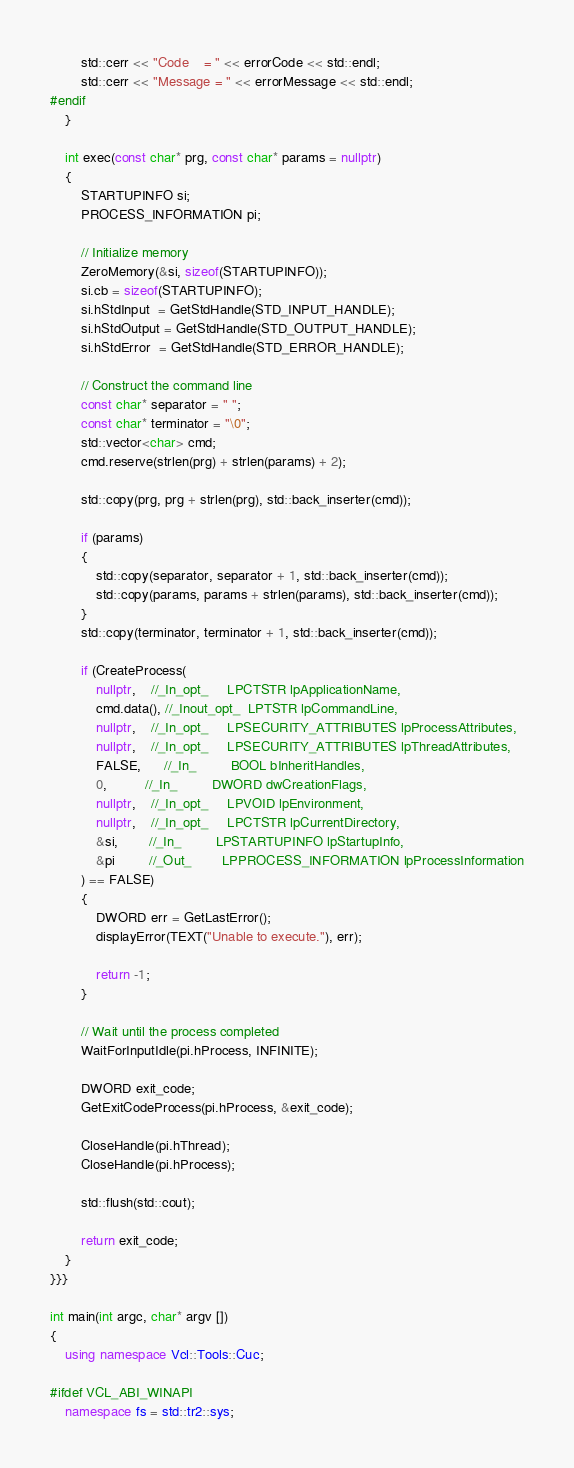Convert code to text. <code><loc_0><loc_0><loc_500><loc_500><_C++_>		std::cerr << "Code    = " << errorCode << std::endl;
		std::cerr << "Message = " << errorMessage << std::endl;
#endif
	}

	int exec(const char* prg, const char* params = nullptr)
	{
		STARTUPINFO si;
		PROCESS_INFORMATION pi;

		// Initialize memory
		ZeroMemory(&si, sizeof(STARTUPINFO));
		si.cb = sizeof(STARTUPINFO);
		si.hStdInput  = GetStdHandle(STD_INPUT_HANDLE);
		si.hStdOutput = GetStdHandle(STD_OUTPUT_HANDLE);
		si.hStdError  = GetStdHandle(STD_ERROR_HANDLE);
		
		// Construct the command line
		const char* separator = " ";
		const char* terminator = "\0";
		std::vector<char> cmd;
		cmd.reserve(strlen(prg) + strlen(params) + 2);

		std::copy(prg, prg + strlen(prg), std::back_inserter(cmd));

		if (params)
		{
			std::copy(separator, separator + 1, std::back_inserter(cmd));
			std::copy(params, params + strlen(params), std::back_inserter(cmd));
		}
		std::copy(terminator, terminator + 1, std::back_inserter(cmd));

		if (CreateProcess(
			nullptr,    //_In_opt_     LPCTSTR lpApplicationName,
			cmd.data(), //_Inout_opt_  LPTSTR lpCommandLine,
			nullptr,    //_In_opt_     LPSECURITY_ATTRIBUTES lpProcessAttributes,
			nullptr,    //_In_opt_     LPSECURITY_ATTRIBUTES lpThreadAttributes,
			FALSE,      //_In_         BOOL bInheritHandles,
			0,          //_In_         DWORD dwCreationFlags,
			nullptr,    //_In_opt_     LPVOID lpEnvironment,
			nullptr,    //_In_opt_     LPCTSTR lpCurrentDirectory,
			&si,        //_In_         LPSTARTUPINFO lpStartupInfo,
			&pi         //_Out_        LPPROCESS_INFORMATION lpProcessInformation
		) == FALSE)
		{
			DWORD err = GetLastError();
			displayError(TEXT("Unable to execute."), err);

			return -1;
		}

		// Wait until the process completed
		WaitForInputIdle(pi.hProcess, INFINITE);

		DWORD exit_code;
		GetExitCodeProcess(pi.hProcess, &exit_code);

		CloseHandle(pi.hThread);
		CloseHandle(pi.hProcess);

		std::flush(std::cout);

		return exit_code;
	}
}}}

int main(int argc, char* argv [])
{
	using namespace Vcl::Tools::Cuc;

#ifdef VCL_ABI_WINAPI
	namespace fs = std::tr2::sys;</code> 